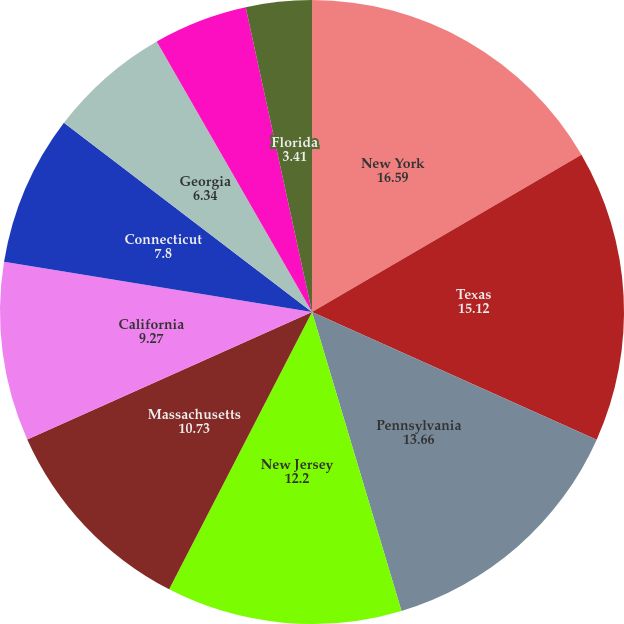Convert chart to OTSL. <chart><loc_0><loc_0><loc_500><loc_500><pie_chart><fcel>New York<fcel>Texas<fcel>Pennsylvania<fcel>New Jersey<fcel>Massachusetts<fcel>California<fcel>Connecticut<fcel>Georgia<fcel>Virginia<fcel>Florida<nl><fcel>16.59%<fcel>15.12%<fcel>13.66%<fcel>12.2%<fcel>10.73%<fcel>9.27%<fcel>7.8%<fcel>6.34%<fcel>4.88%<fcel>3.41%<nl></chart> 